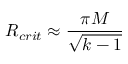<formula> <loc_0><loc_0><loc_500><loc_500>R _ { c r i t } \approx { \frac { \pi M } { \sqrt { k - 1 } } }</formula> 